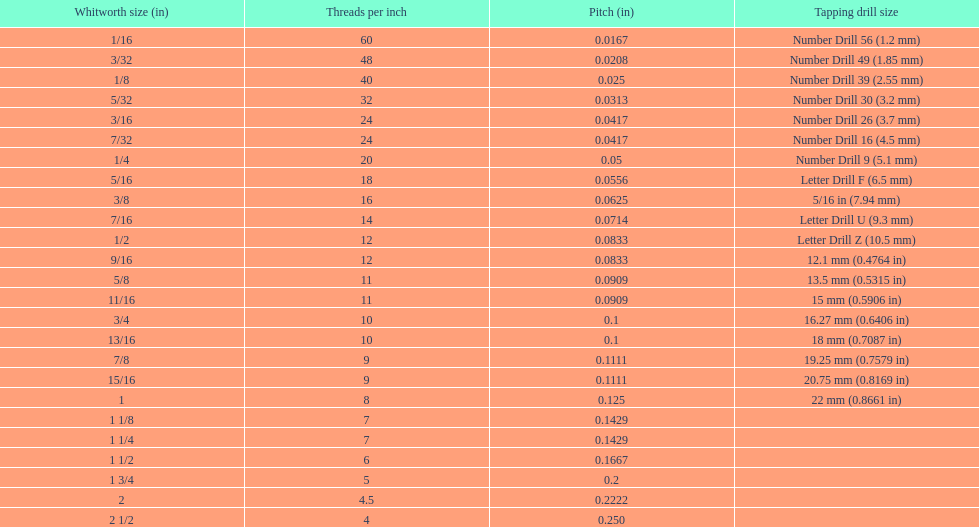Which whitworth size has the same number of threads per inch as 3/16? 7/32. 